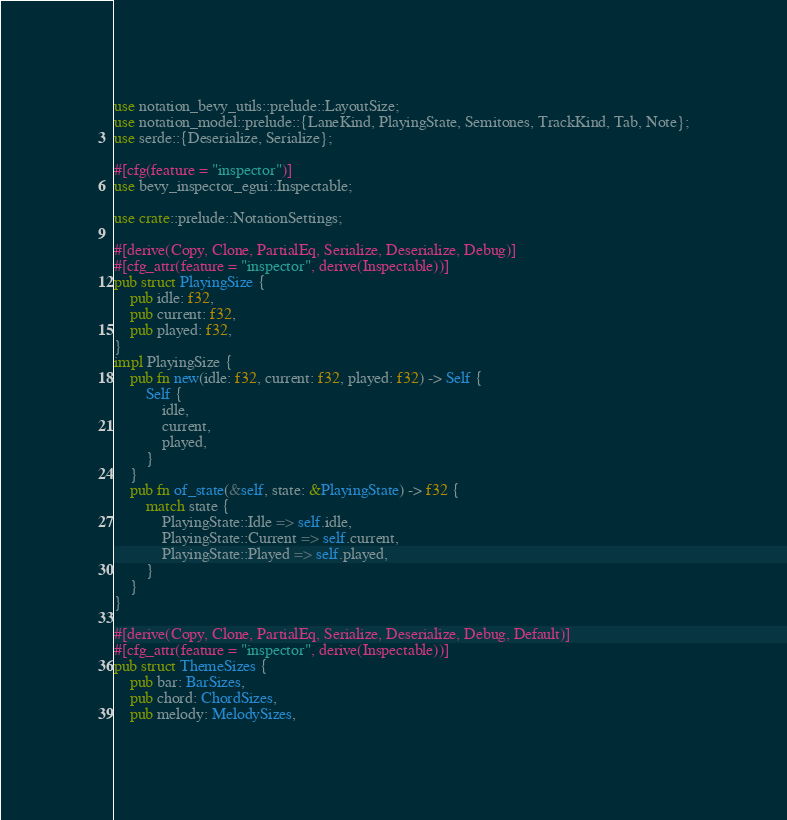<code> <loc_0><loc_0><loc_500><loc_500><_Rust_>use notation_bevy_utils::prelude::LayoutSize;
use notation_model::prelude::{LaneKind, PlayingState, Semitones, TrackKind, Tab, Note};
use serde::{Deserialize, Serialize};

#[cfg(feature = "inspector")]
use bevy_inspector_egui::Inspectable;

use crate::prelude::NotationSettings;

#[derive(Copy, Clone, PartialEq, Serialize, Deserialize, Debug)]
#[cfg_attr(feature = "inspector", derive(Inspectable))]
pub struct PlayingSize {
    pub idle: f32,
    pub current: f32,
    pub played: f32,
}
impl PlayingSize {
    pub fn new(idle: f32, current: f32, played: f32) -> Self {
        Self {
            idle,
            current,
            played,
        }
    }
    pub fn of_state(&self, state: &PlayingState) -> f32 {
        match state {
            PlayingState::Idle => self.idle,
            PlayingState::Current => self.current,
            PlayingState::Played => self.played,
        }
    }
}

#[derive(Copy, Clone, PartialEq, Serialize, Deserialize, Debug, Default)]
#[cfg_attr(feature = "inspector", derive(Inspectable))]
pub struct ThemeSizes {
    pub bar: BarSizes,
    pub chord: ChordSizes,
    pub melody: MelodySizes,</code> 